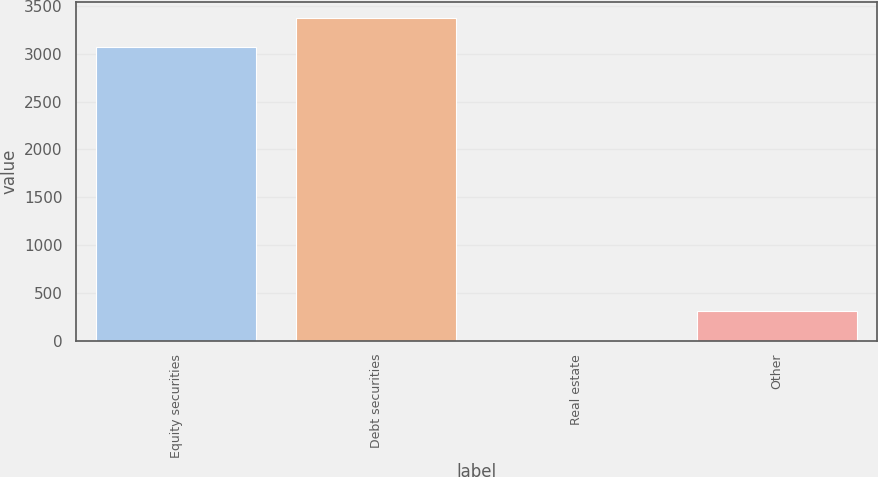<chart> <loc_0><loc_0><loc_500><loc_500><bar_chart><fcel>Equity securities<fcel>Debt securities<fcel>Real estate<fcel>Other<nl><fcel>3065<fcel>3370.5<fcel>10<fcel>315.5<nl></chart> 